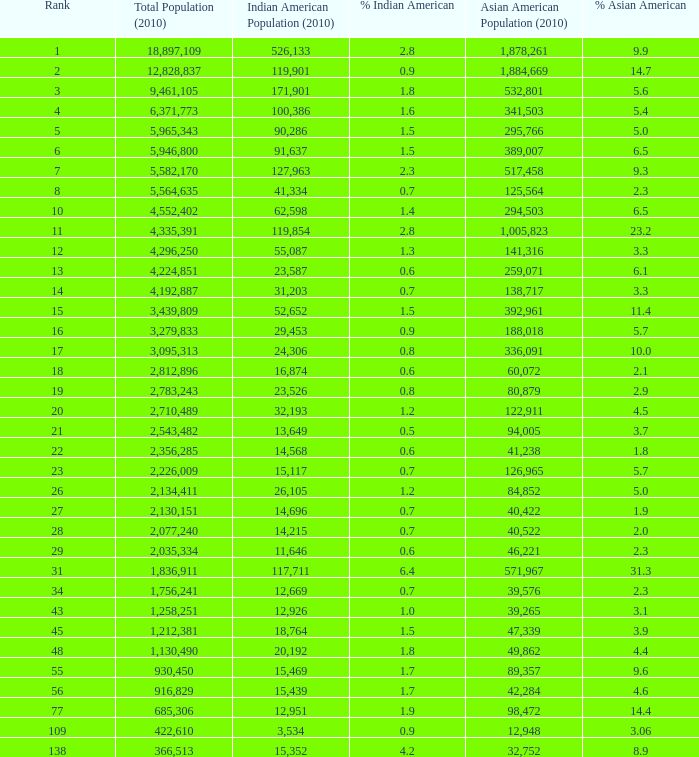What is the complete population when the asian american population is fewer than 60,072, the indian american population is greater than 14,696, and it comprises 366513.0. Can you give me this table as a dict? {'header': ['Rank', 'Total Population (2010)', 'Indian American Population (2010)', '% Indian American', 'Asian American Population (2010)', '% Asian American'], 'rows': [['1', '18,897,109', '526,133', '2.8', '1,878,261', '9.9'], ['2', '12,828,837', '119,901', '0.9', '1,884,669', '14.7'], ['3', '9,461,105', '171,901', '1.8', '532,801', '5.6'], ['4', '6,371,773', '100,386', '1.6', '341,503', '5.4'], ['5', '5,965,343', '90,286', '1.5', '295,766', '5.0'], ['6', '5,946,800', '91,637', '1.5', '389,007', '6.5'], ['7', '5,582,170', '127,963', '2.3', '517,458', '9.3'], ['8', '5,564,635', '41,334', '0.7', '125,564', '2.3'], ['10', '4,552,402', '62,598', '1.4', '294,503', '6.5'], ['11', '4,335,391', '119,854', '2.8', '1,005,823', '23.2'], ['12', '4,296,250', '55,087', '1.3', '141,316', '3.3'], ['13', '4,224,851', '23,587', '0.6', '259,071', '6.1'], ['14', '4,192,887', '31,203', '0.7', '138,717', '3.3'], ['15', '3,439,809', '52,652', '1.5', '392,961', '11.4'], ['16', '3,279,833', '29,453', '0.9', '188,018', '5.7'], ['17', '3,095,313', '24,306', '0.8', '336,091', '10.0'], ['18', '2,812,896', '16,874', '0.6', '60,072', '2.1'], ['19', '2,783,243', '23,526', '0.8', '80,879', '2.9'], ['20', '2,710,489', '32,193', '1.2', '122,911', '4.5'], ['21', '2,543,482', '13,649', '0.5', '94,005', '3.7'], ['22', '2,356,285', '14,568', '0.6', '41,238', '1.8'], ['23', '2,226,009', '15,117', '0.7', '126,965', '5.7'], ['26', '2,134,411', '26,105', '1.2', '84,852', '5.0'], ['27', '2,130,151', '14,696', '0.7', '40,422', '1.9'], ['28', '2,077,240', '14,215', '0.7', '40,522', '2.0'], ['29', '2,035,334', '11,646', '0.6', '46,221', '2.3'], ['31', '1,836,911', '117,711', '6.4', '571,967', '31.3'], ['34', '1,756,241', '12,669', '0.7', '39,576', '2.3'], ['43', '1,258,251', '12,926', '1.0', '39,265', '3.1'], ['45', '1,212,381', '18,764', '1.5', '47,339', '3.9'], ['48', '1,130,490', '20,192', '1.8', '49,862', '4.4'], ['55', '930,450', '15,469', '1.7', '89,357', '9.6'], ['56', '916,829', '15,439', '1.7', '42,284', '4.6'], ['77', '685,306', '12,951', '1.9', '98,472', '14.4'], ['109', '422,610', '3,534', '0.9', '12,948', '3.06'], ['138', '366,513', '15,352', '4.2', '32,752', '8.9']]} 